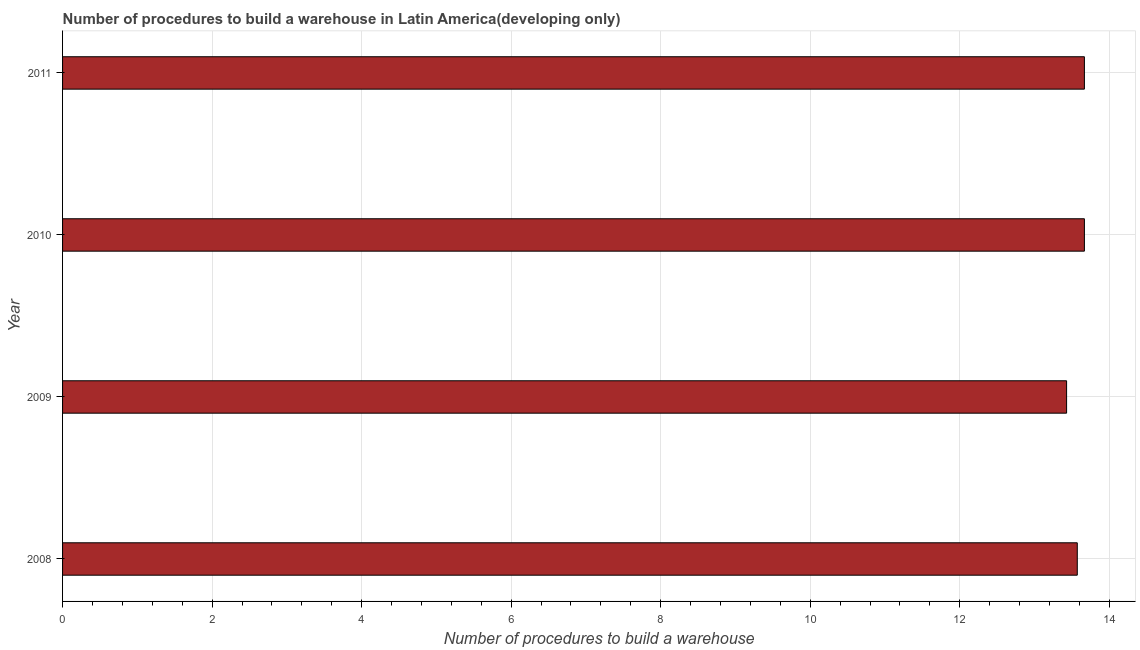Does the graph contain any zero values?
Provide a succinct answer. No. What is the title of the graph?
Your response must be concise. Number of procedures to build a warehouse in Latin America(developing only). What is the label or title of the X-axis?
Ensure brevity in your answer.  Number of procedures to build a warehouse. What is the label or title of the Y-axis?
Provide a short and direct response. Year. What is the number of procedures to build a warehouse in 2011?
Offer a terse response. 13.67. Across all years, what is the maximum number of procedures to build a warehouse?
Provide a short and direct response. 13.67. Across all years, what is the minimum number of procedures to build a warehouse?
Make the answer very short. 13.43. In which year was the number of procedures to build a warehouse maximum?
Keep it short and to the point. 2010. What is the sum of the number of procedures to build a warehouse?
Your answer should be very brief. 54.33. What is the difference between the number of procedures to build a warehouse in 2008 and 2011?
Your answer should be compact. -0.1. What is the average number of procedures to build a warehouse per year?
Offer a very short reply. 13.58. What is the median number of procedures to build a warehouse?
Offer a terse response. 13.62. What is the difference between the highest and the second highest number of procedures to build a warehouse?
Give a very brief answer. 0. What is the difference between the highest and the lowest number of procedures to build a warehouse?
Ensure brevity in your answer.  0.24. In how many years, is the number of procedures to build a warehouse greater than the average number of procedures to build a warehouse taken over all years?
Your answer should be very brief. 2. What is the difference between two consecutive major ticks on the X-axis?
Ensure brevity in your answer.  2. Are the values on the major ticks of X-axis written in scientific E-notation?
Your answer should be compact. No. What is the Number of procedures to build a warehouse in 2008?
Your answer should be very brief. 13.57. What is the Number of procedures to build a warehouse of 2009?
Your answer should be compact. 13.43. What is the Number of procedures to build a warehouse in 2010?
Make the answer very short. 13.67. What is the Number of procedures to build a warehouse in 2011?
Your answer should be compact. 13.67. What is the difference between the Number of procedures to build a warehouse in 2008 and 2009?
Your response must be concise. 0.14. What is the difference between the Number of procedures to build a warehouse in 2008 and 2010?
Provide a short and direct response. -0.1. What is the difference between the Number of procedures to build a warehouse in 2008 and 2011?
Provide a succinct answer. -0.1. What is the difference between the Number of procedures to build a warehouse in 2009 and 2010?
Your response must be concise. -0.24. What is the difference between the Number of procedures to build a warehouse in 2009 and 2011?
Your response must be concise. -0.24. What is the difference between the Number of procedures to build a warehouse in 2010 and 2011?
Keep it short and to the point. 0. What is the ratio of the Number of procedures to build a warehouse in 2008 to that in 2009?
Ensure brevity in your answer.  1.01. 